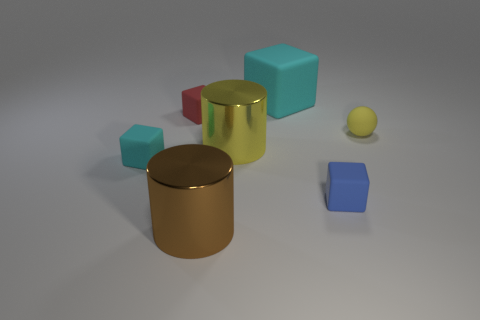Add 3 tiny brown metal things. How many objects exist? 10 Subtract all cylinders. How many objects are left? 5 Add 5 blue blocks. How many blue blocks exist? 6 Subtract 0 red cylinders. How many objects are left? 7 Subtract all small cyan cubes. Subtract all cyan matte blocks. How many objects are left? 4 Add 5 yellow metallic cylinders. How many yellow metallic cylinders are left? 6 